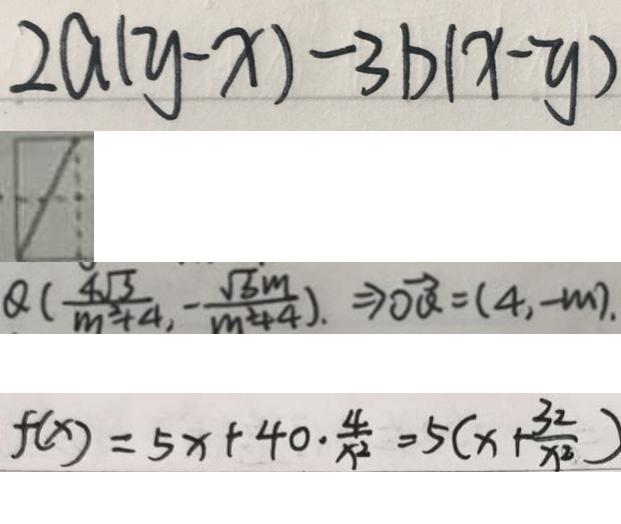Convert formula to latex. <formula><loc_0><loc_0><loc_500><loc_500>2 a ( y - x ) - 3 b ( x - y ) 
 1 
 Q ( \frac { 4 \sqrt { 3 } } { m ^ { 2 } + 4 } , \frac { \sqrt { 3 } m } { m ^ { 2 } + 4 } ) , \rightarrow \overrightarrow { O Q } = ( 4 , - m ) . 
 f ( x ) = 5 x + 4 0 \cdot \frac { 4 } { x ^ { 2 } } = 5 ( x + \frac { 3 2 } { x ^ { 2 } } )</formula> 